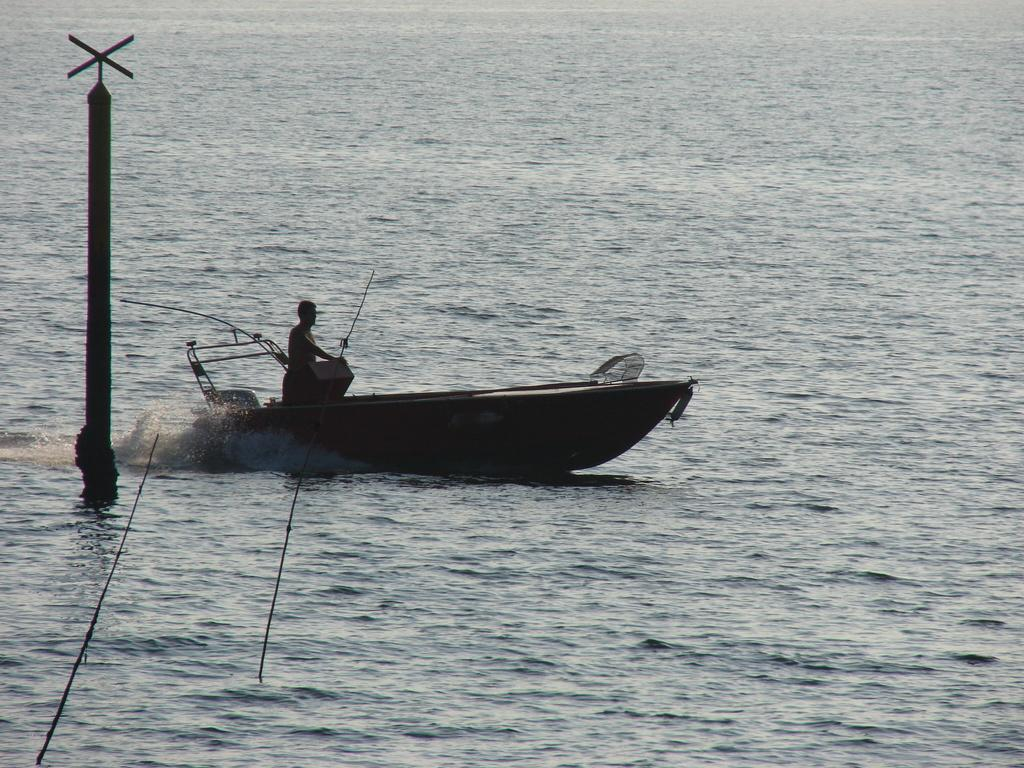What is the person in the image doing? There is a person standing on a boat in the image. Where is the boat located? The boat is on a river. What can be seen in the image besides the person and the boat? There is a pole in the image. How does the person in the image grip the wave? There is no wave present in the image, and therefore no gripping is taking place. 